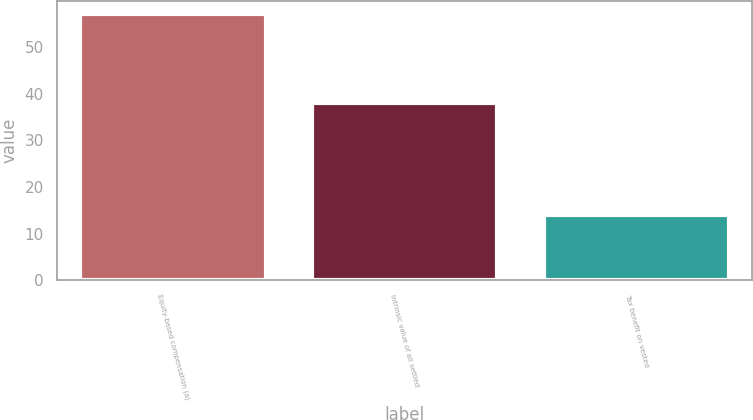Convert chart. <chart><loc_0><loc_0><loc_500><loc_500><bar_chart><fcel>Equity-based compensation (a)<fcel>Intrinsic value of all settled<fcel>Tax benefit on vested<nl><fcel>57<fcel>38<fcel>14<nl></chart> 